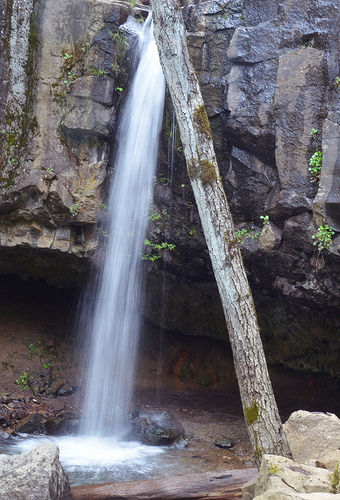<image>
Is there a tree in the waterfall? No. The tree is not contained within the waterfall. These objects have a different spatial relationship. 